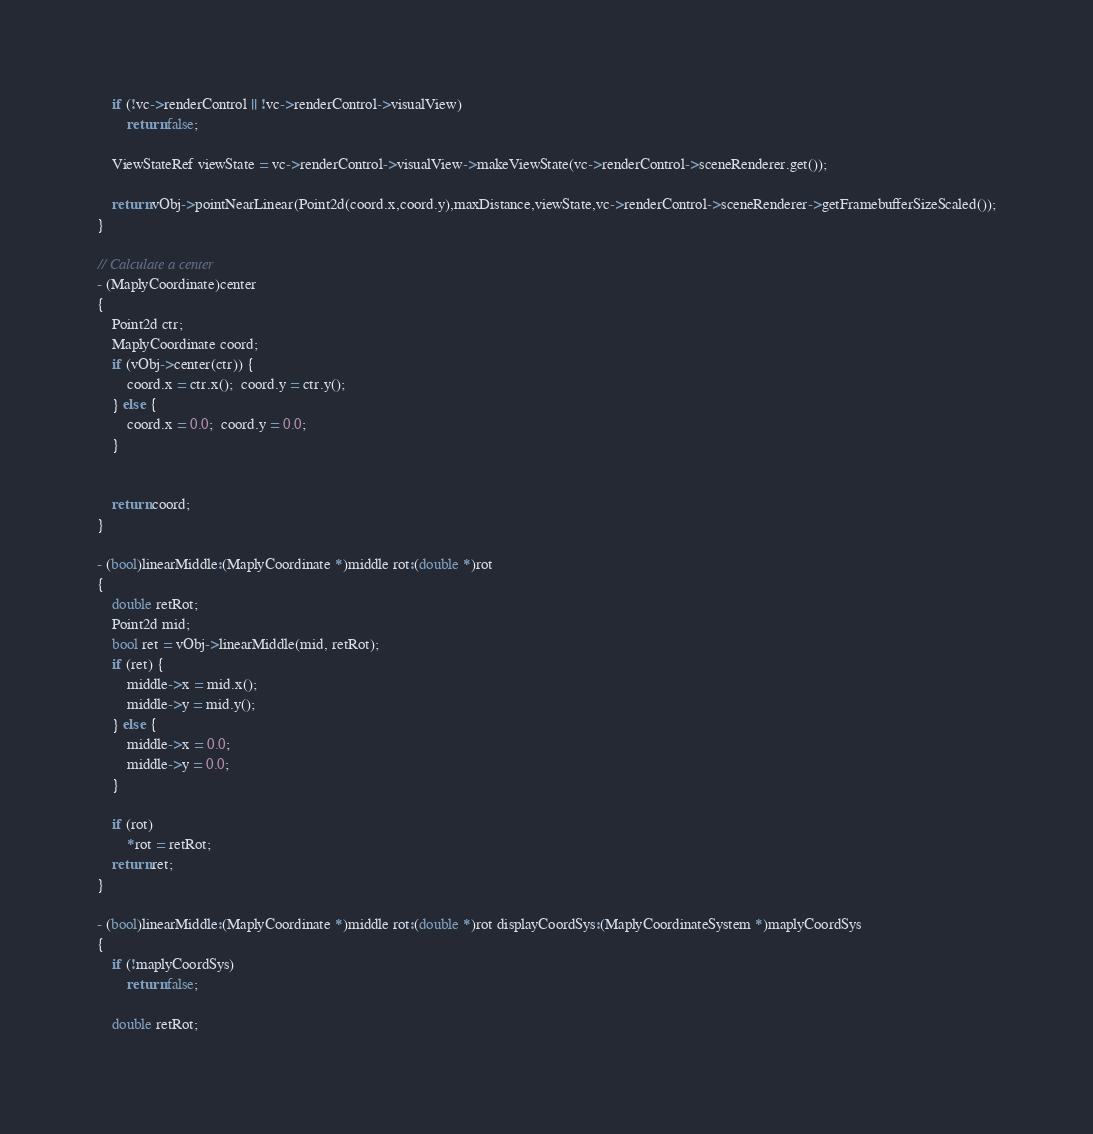<code> <loc_0><loc_0><loc_500><loc_500><_ObjectiveC_>    if (!vc->renderControl || !vc->renderControl->visualView)
        return false;
    
    ViewStateRef viewState = vc->renderControl->visualView->makeViewState(vc->renderControl->sceneRenderer.get());

    return vObj->pointNearLinear(Point2d(coord.x,coord.y),maxDistance,viewState,vc->renderControl->sceneRenderer->getFramebufferSizeScaled());
}

// Calculate a center
- (MaplyCoordinate)center
{
    Point2d ctr;
    MaplyCoordinate coord;
    if (vObj->center(ctr)) {
        coord.x = ctr.x();  coord.y = ctr.y();
    } else {
        coord.x = 0.0;  coord.y = 0.0;
    }
    
    
    return coord;
}

- (bool)linearMiddle:(MaplyCoordinate *)middle rot:(double *)rot
{
    double retRot;
    Point2d mid;
    bool ret = vObj->linearMiddle(mid, retRot);
    if (ret) {
        middle->x = mid.x();
        middle->y = mid.y();
    } else {
        middle->x = 0.0;
        middle->y = 0.0;
    }
    
    if (rot)
        *rot = retRot;
    return ret;
}

- (bool)linearMiddle:(MaplyCoordinate *)middle rot:(double *)rot displayCoordSys:(MaplyCoordinateSystem *)maplyCoordSys
{
    if (!maplyCoordSys)
        return false;

    double retRot;</code> 